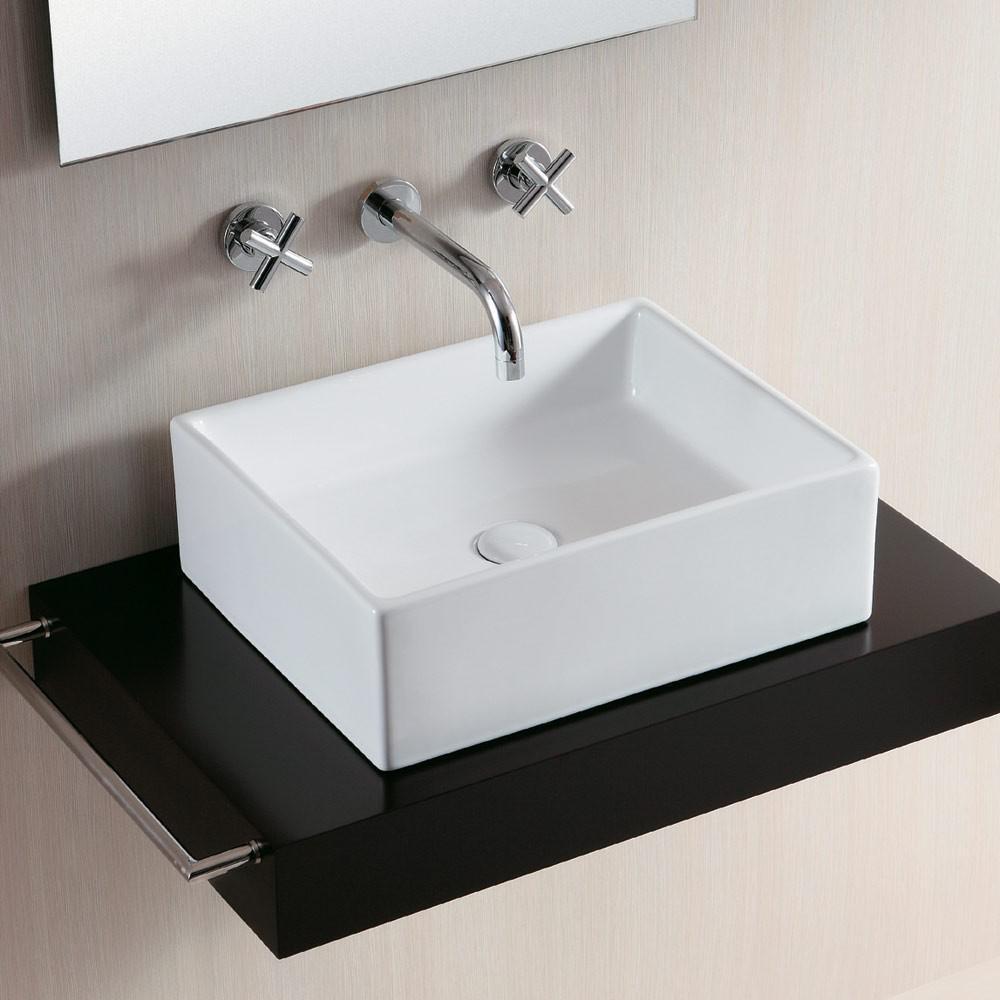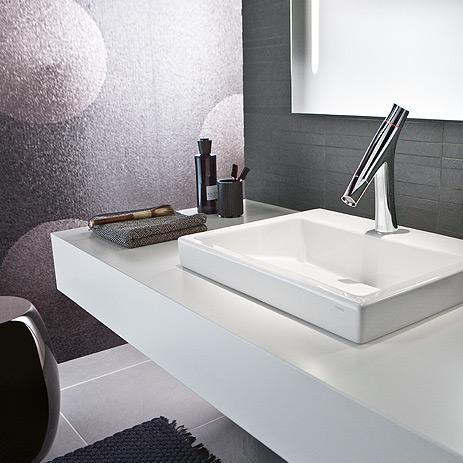The first image is the image on the left, the second image is the image on the right. Examine the images to the left and right. Is the description "An image shows at least one square white sink atop a black base and under a spout mounted to the wall." accurate? Answer yes or no. Yes. The first image is the image on the left, the second image is the image on the right. Assess this claim about the two images: "There are at least two rectangular basins.". Correct or not? Answer yes or no. Yes. 